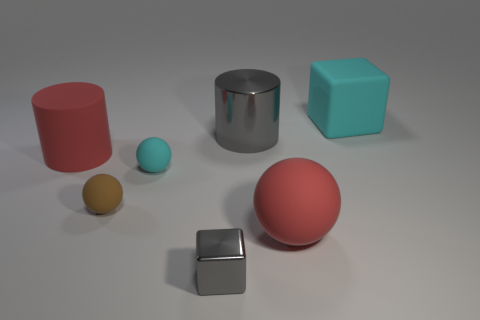Do the gray cube that is in front of the cyan rubber sphere and the large gray object have the same material? Indeed, both the gray cube in front of the cyan rubber sphere and the large gray object appear to have the same metallic sheen and reflective qualities, indicating that they are made from a metal or metal-like material. 